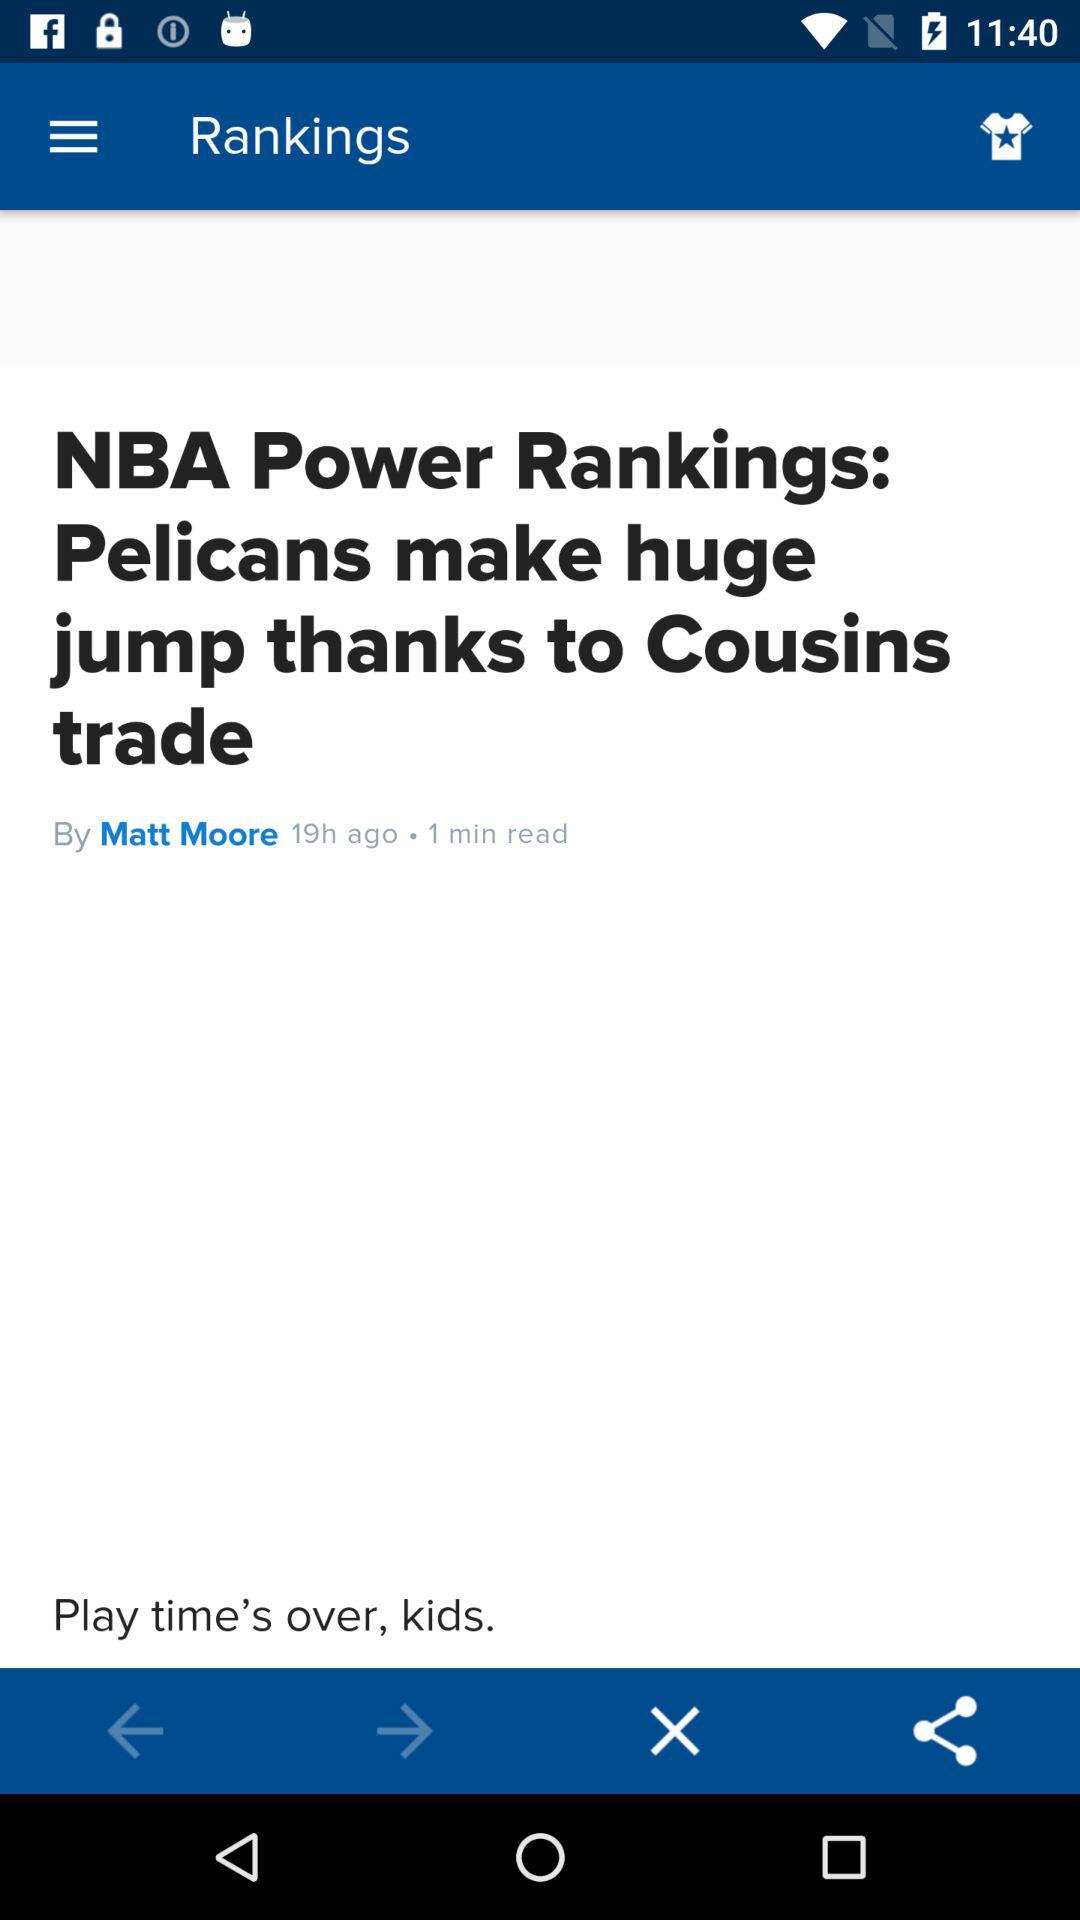Who is the author? The author is "Matt Moore". 